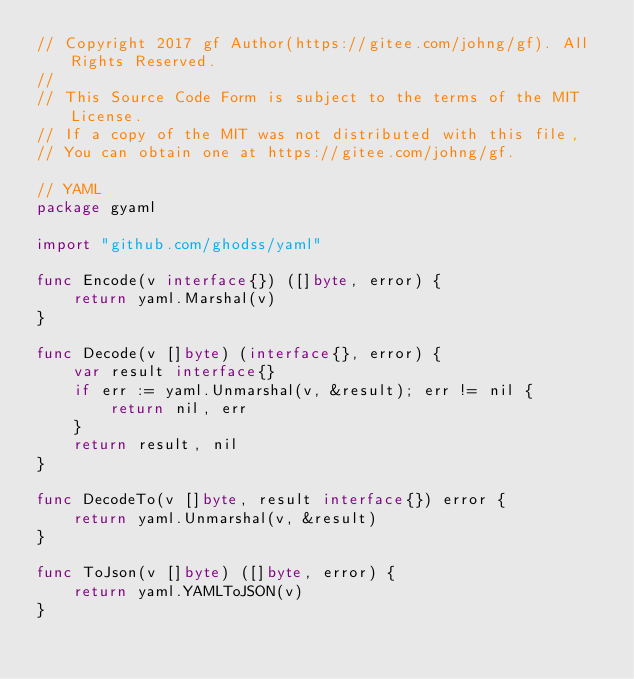Convert code to text. <code><loc_0><loc_0><loc_500><loc_500><_Go_>// Copyright 2017 gf Author(https://gitee.com/johng/gf). All Rights Reserved.
//
// This Source Code Form is subject to the terms of the MIT License.
// If a copy of the MIT was not distributed with this file,
// You can obtain one at https://gitee.com/johng/gf.

// YAML
package gyaml

import "github.com/ghodss/yaml"

func Encode(v interface{}) ([]byte, error) {
    return yaml.Marshal(v)
}

func Decode(v []byte) (interface{}, error) {
    var result interface{}
    if err := yaml.Unmarshal(v, &result); err != nil {
        return nil, err
    }
    return result, nil
}

func DecodeTo(v []byte, result interface{}) error {
    return yaml.Unmarshal(v, &result)
}

func ToJson(v []byte) ([]byte, error) {
    return yaml.YAMLToJSON(v)
}</code> 